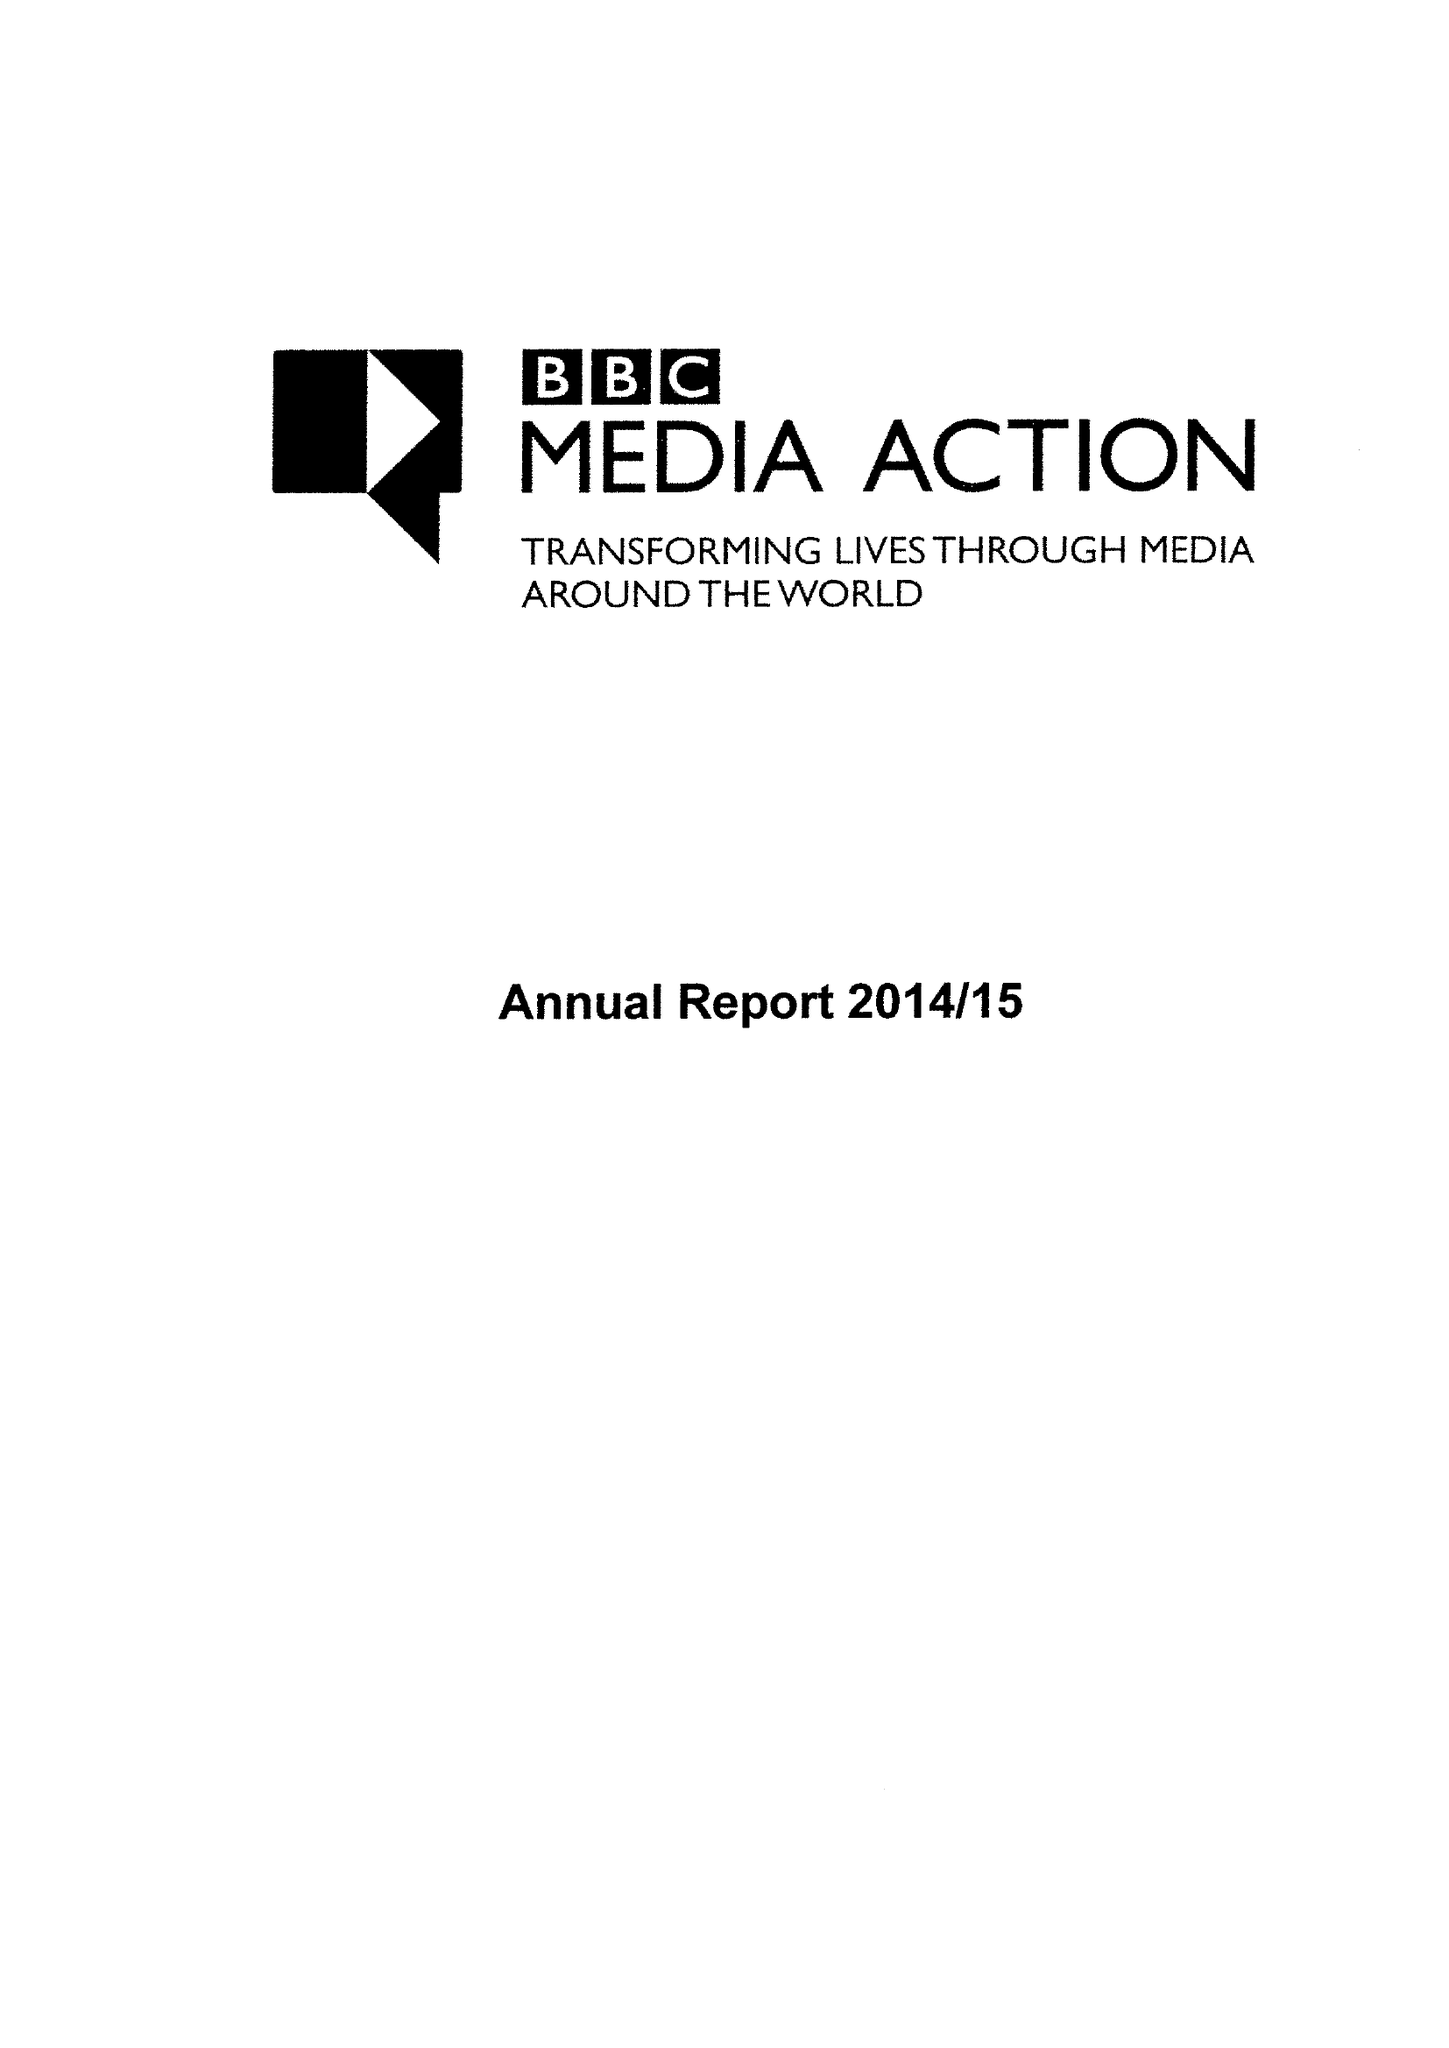What is the value for the income_annually_in_british_pounds?
Answer the question using a single word or phrase. 47435000.00 